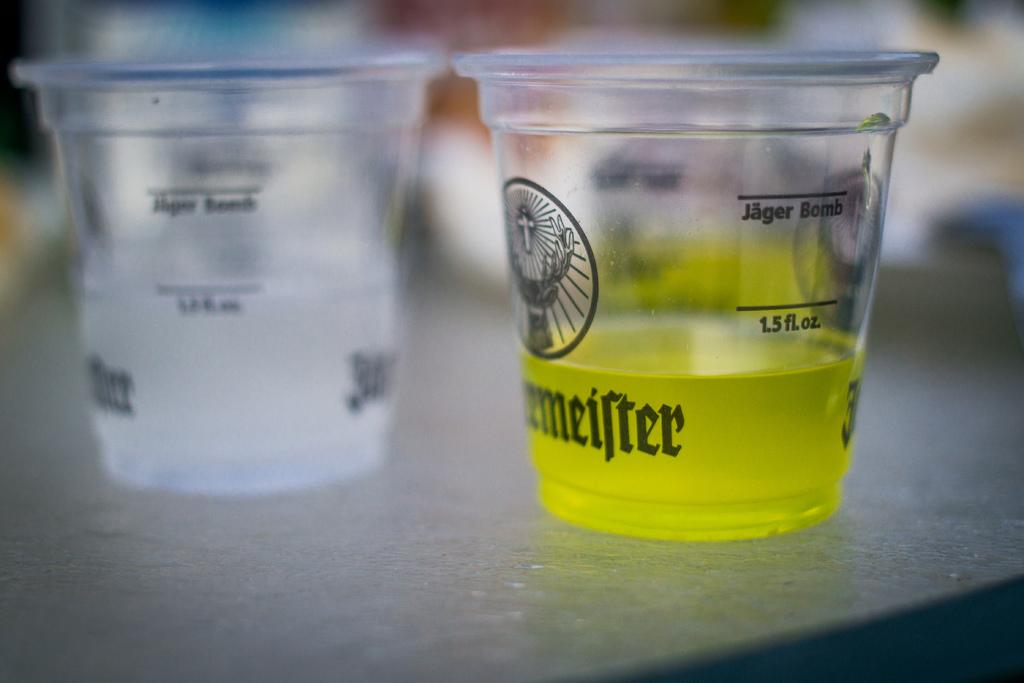How many glasses can be seen in the image? There are two glasses in the image. What is inside the glasses? There is liquid in the glasses. Can you describe the background of the image? The background of the image is blurred. What type of jeans can be seen in the image? There are no jeans present in the image. What causes the liquid in the glasses to burst in the image? The liquid in the glasses does not burst in the image; it is contained within the glasses. 